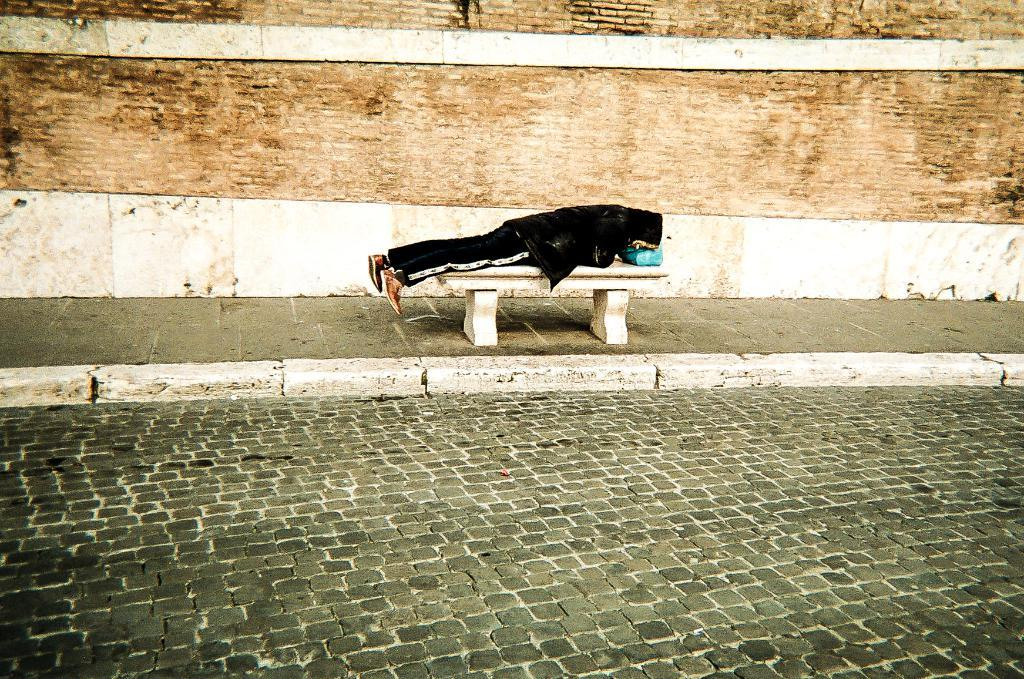What is the person in the image doing? The person is lying on a bench in the image. What can be seen at the bottom of the image? A road is visible at the bottom of the image. What is in the background of the image? There is a brick wall in the background of the image. Where is the bucket located in the image? There is no bucket present in the image. What type of account does the person have at the seashore? There is no seashore or account mentioned in the image; it only features a person lying on a bench, a road, and a brick wall. 